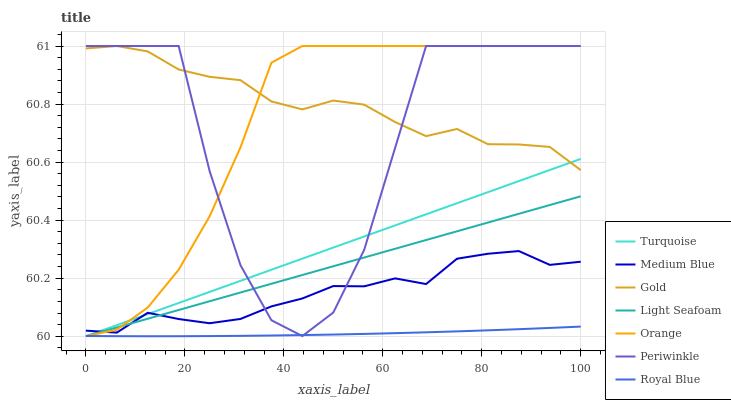Does Royal Blue have the minimum area under the curve?
Answer yes or no. Yes. Does Gold have the maximum area under the curve?
Answer yes or no. Yes. Does Medium Blue have the minimum area under the curve?
Answer yes or no. No. Does Medium Blue have the maximum area under the curve?
Answer yes or no. No. Is Light Seafoam the smoothest?
Answer yes or no. Yes. Is Periwinkle the roughest?
Answer yes or no. Yes. Is Gold the smoothest?
Answer yes or no. No. Is Gold the roughest?
Answer yes or no. No. Does Medium Blue have the lowest value?
Answer yes or no. No. Does Orange have the highest value?
Answer yes or no. Yes. Does Medium Blue have the highest value?
Answer yes or no. No. Is Royal Blue less than Gold?
Answer yes or no. Yes. Is Gold greater than Royal Blue?
Answer yes or no. Yes. Does Turquoise intersect Gold?
Answer yes or no. Yes. Is Turquoise less than Gold?
Answer yes or no. No. Is Turquoise greater than Gold?
Answer yes or no. No. Does Royal Blue intersect Gold?
Answer yes or no. No. 